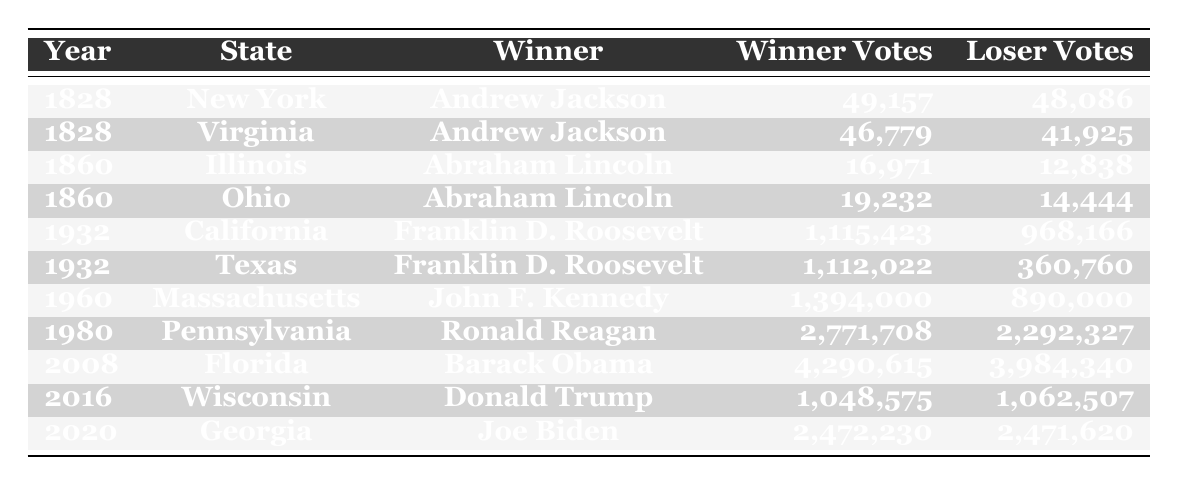What was the winning candidate in New York in 1828? The table shows that the winner in New York in 1828 was Andrew Jackson.
Answer: Andrew Jackson Which candidate received the most votes in the 1932 California election? In 1932 California, Franklin D. Roosevelt received 1,115,423 votes, which is more than Herbert Hoover's 968,166 votes.
Answer: Franklin D. Roosevelt What was the vote difference between the winning and losing candidates in the 2020 Georgia election? The winning candidate, Joe Biden, received 2,472,230 votes while the losing candidate, Donald Trump, received 2,471,620 votes. The difference is 2,472,230 - 2,471,620 = 610 votes.
Answer: 610 Was Abraham Lincoln the winning candidate in Ohio in 1860? Yes, Abraham Lincoln was listed as the winning candidate in Ohio in 1860, according to the table.
Answer: Yes In which state did Ronald Reagan win in 1980 and how many votes did he secure? The table indicates that Ronald Reagan won in Pennsylvania in 1980 with 2,771,708 votes.
Answer: Pennsylvania, 2,771,708 votes What was the average number of winning votes for the years represented in the table? To find the average, sum all winning votes: (49,157 + 46,779 + 16,971 + 19,232 + 1,115,423 + 1,112,022 + 1,394,000 + 2,771,708 + 4,290,615 + 1,048,575 + 2,472,230) = 14,966,653. There are 11 data points, so the average is 14,966,653 / 11 ≈ 1,360,605.
Answer: Approximately 1,360,605 Which state had the closest election result in terms of winning and losing votes? The table reveals that Georgia in 2020 had the closest result with a mere 610 vote difference between Joe Biden and Donald Trump.
Answer: Georgia How many total votes were cast in the Wisconsin election in 2016? To find the total votes, add the winning and losing votes from Wisconsin in 2016: 1,048,575 + 1,062,507 = 2,111,082 votes.
Answer: 2,111,082 votes What was the trend of votes for Joe Biden compared to Donald Trump in the 2020 Georgia election? In the 2020 Georgia election, Joe Biden won by receiving 2,472,230 votes compared to Donald Trump's 2,471,620 votes, indicating a narrow victory.
Answer: Joe Biden won by 610 votes Which candidate had the highest vote count across all elections represented? The highest vote count in the table is 4,290,615 votes for Barack Obama in Florida in 2008.
Answer: Barack Obama 